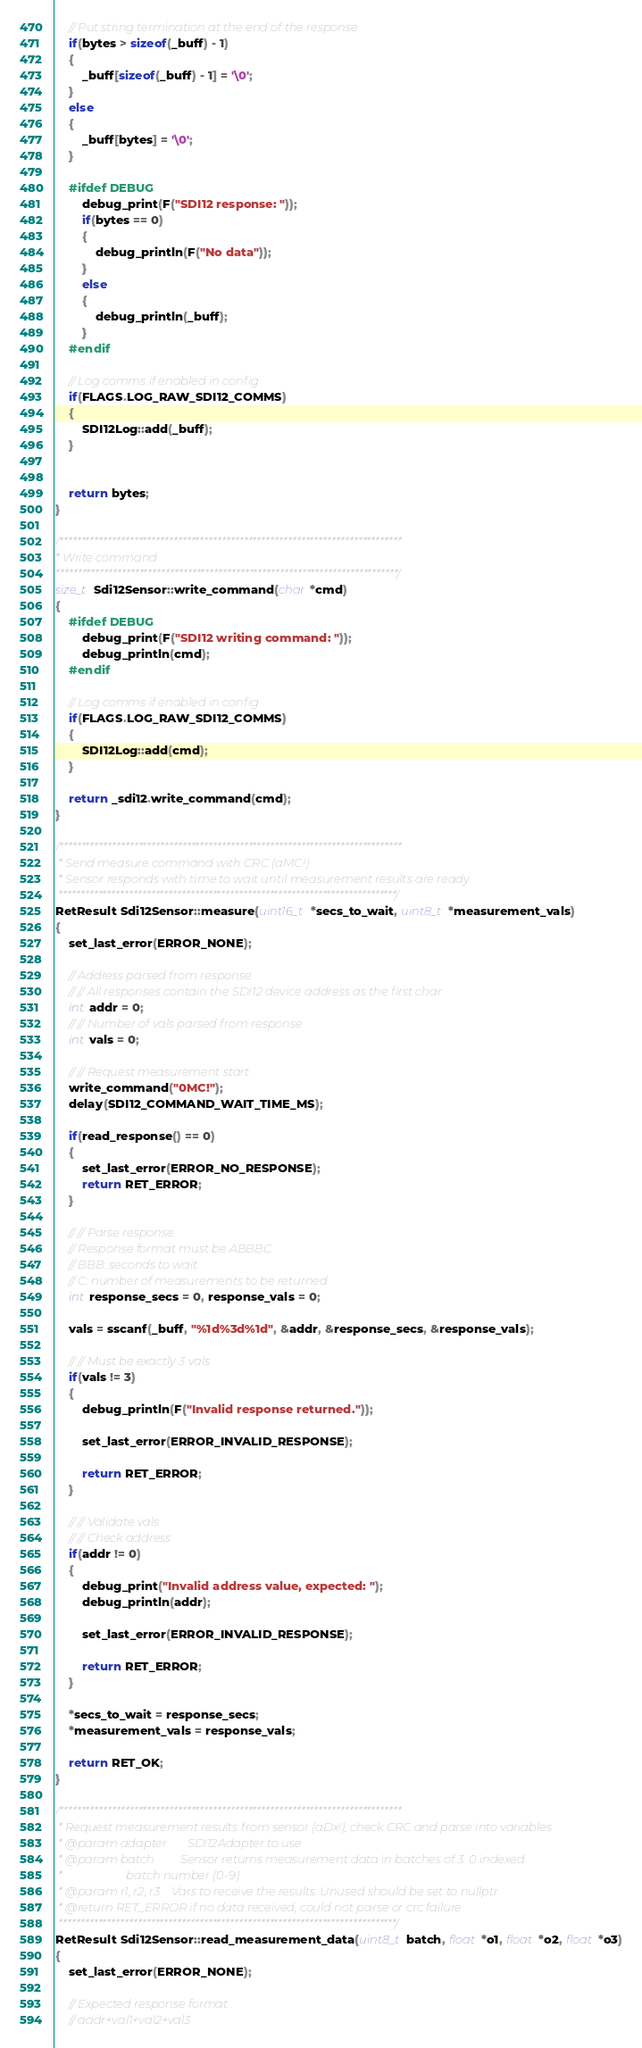<code> <loc_0><loc_0><loc_500><loc_500><_C++_>    // Put string termination at the end of the response
    if(bytes > sizeof(_buff) - 1)
    {
        _buff[sizeof(_buff) - 1] = '\0';
    }
    else
    {
        _buff[bytes] = '\0';
    }

    #ifdef DEBUG
        debug_print(F("SDI12 response: "));
        if(bytes == 0)
        {
            debug_println(F("No data"));
        }
        else
        {
            debug_println(_buff);
        }
    #endif

	// Log comms if enabled in config
	if(FLAGS.LOG_RAW_SDI12_COMMS)
	{
		SDI12Log::add(_buff);
	}	


    return bytes;
}

/******************************************************************************
* Write command
******************************************************************************/
size_t Sdi12Sensor::write_command(char *cmd)
{
    #ifdef DEBUG
        debug_print(F("SDI12 writing command: "));
        debug_println(cmd);
    #endif

	// Log comms if enabled in config
	if(FLAGS.LOG_RAW_SDI12_COMMS)
	{
		SDI12Log::add(cmd);
	}	

    return _sdi12.write_command(cmd);
}

/******************************************************************************
 * Send measure command with CRC (aMC!)
 * Sensor responds with time to wait until measurement results are ready
 *****************************************************************************/
RetResult Sdi12Sensor::measure(uint16_t *secs_to_wait, uint8_t *measurement_vals)
{
    set_last_error(ERROR_NONE);

	// Address parsed from response
	// // All responses contain the SDI12 device address as the first char
	int addr = 0;
	// // Number of vals parsed from response
	int vals = 0;

	// // Request measurement start
    write_command("0MC!");
	delay(SDI12_COMMAND_WAIT_TIME_MS);
	
    if(read_response() == 0)
    {
        set_last_error(ERROR_NO_RESPONSE);
        return RET_ERROR;
    }

	// // Parse response.
	// Response format must be ABBBC
	// BBB: seconds to wait
	// C: number of measurements to be returned
	int response_secs = 0, response_vals = 0;

	vals = sscanf(_buff, "%1d%3d%1d", &addr, &response_secs, &response_vals);

	// // Must be exactly 3 vals
	if(vals != 3)
	{
		debug_println(F("Invalid response returned."));

		set_last_error(ERROR_INVALID_RESPONSE);

		return RET_ERROR;
	}

	// // Validate vals
	// // Check address
	if(addr != 0)
	{
		debug_print("Invalid address value, expected: ");
		debug_println(addr);

		set_last_error(ERROR_INVALID_RESPONSE);

		return RET_ERROR;
	}

	*secs_to_wait = response_secs;
	*measurement_vals = response_vals;

	return RET_OK;
}

/******************************************************************************
 * Request measurement results from sensor (aDx!), check CRC and parse into variables
 * @param adapter       SDI12Adapter to use
 * @param batch         Sensor returns measurement data in batches of 3. 0 indexed
 *                      batch number (0-9)
 * @param r1, r2, r3    Vars to receive the results. Unused should be set to nullptr
 * @return RET_ERROR if no data received, could not parse or crc failure
 *****************************************************************************/
RetResult Sdi12Sensor::read_measurement_data(uint8_t batch, float *o1, float *o2, float *o3)
{
	set_last_error(ERROR_NONE);

	// Expected response format
	// aadr+val1+val2+val3</code> 